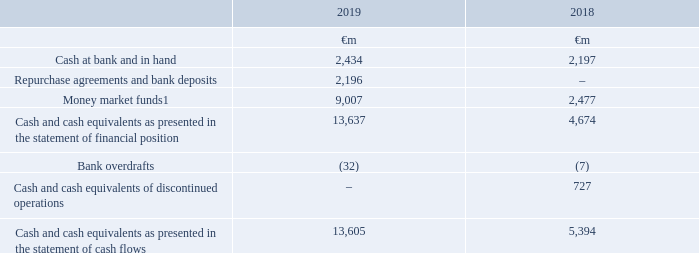19. Cash and cash equivalents
The majority of the Group’s cash is held in bank deposits or money market funds which have a maturity of three months or less to enable us to meet our short-term liquidity requirements.
Accounting policies
Cash and cash equivalents comprise cash in hand and call deposits, and other short-term highly liquid investments that are readily convertible to a known amount of cash and are subject to an insignificant risk of changes in value. Assets in money market funds, whose contractual cash flows do not represent solely payments of interest and principal, are measured at fair value with gains and losses arising from changes in fair value included in net profit or loss for the period. All other cash and cash equivalents are measured at amortised cost.
Note: 1 Items are measured at fair value and the valuation basis is level 1 classification, which comprises financial instruments where fair value is determined by unadjusted quoted prices in active markets.
The carrying amount of balances at amortised cost approximates their fair value.
Cash and cash equivalents of €1,381 million (2018: €1,449 million) are held in countries with restrictions on remittances but where the balances could be used to repay subsidiaries’ third party liabilities.
How long is the maturity period of the group's money market funds? Three months or less. What does cash and cash equivalents comprise of? Cash in hand and call deposits, and other short-term highly liquid investments that are readily convertible to a known amount of cash and are subject to an insignificant risk of changes in value. How much is the 2019 cash at bank and hand ?
Answer scale should be: million. 2,434. Between 2018 and 2019, which year had a greater amount of cash at bank and in hand? 2,434>2,197
Answer: 2019. What is the average money market funds?
Answer scale should be: million. (9,007+2,477)/2
Answer: 5742. What is the average cash and cash equivalents presented in the statement of cash flows?
Answer scale should be: million. (13,605+5,394)/2
Answer: 9499.5. 